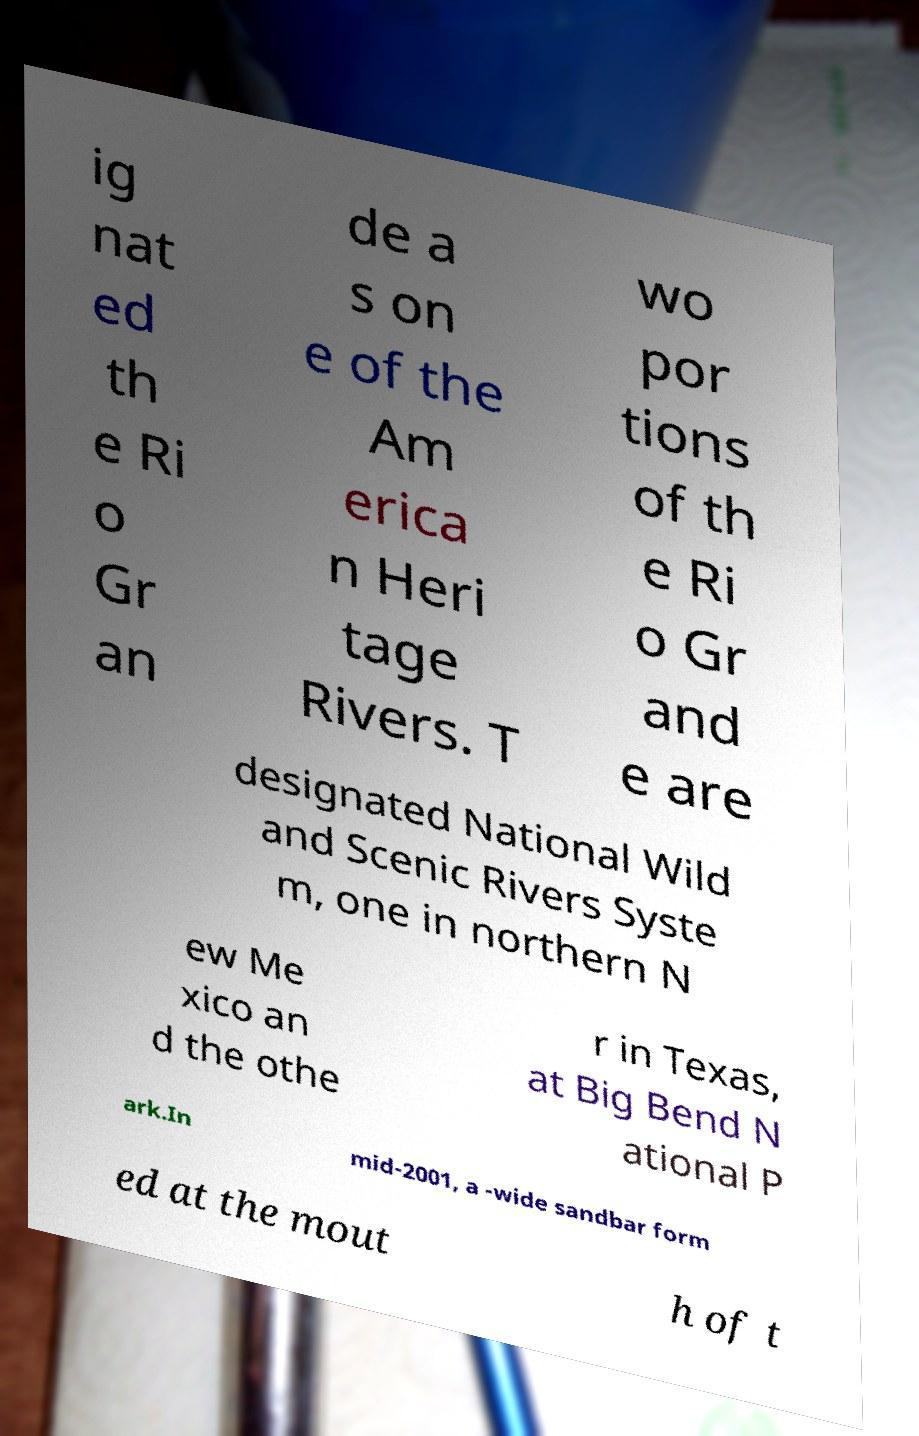What messages or text are displayed in this image? I need them in a readable, typed format. ig nat ed th e Ri o Gr an de a s on e of the Am erica n Heri tage Rivers. T wo por tions of th e Ri o Gr and e are designated National Wild and Scenic Rivers Syste m, one in northern N ew Me xico an d the othe r in Texas, at Big Bend N ational P ark.In mid-2001, a -wide sandbar form ed at the mout h of t 